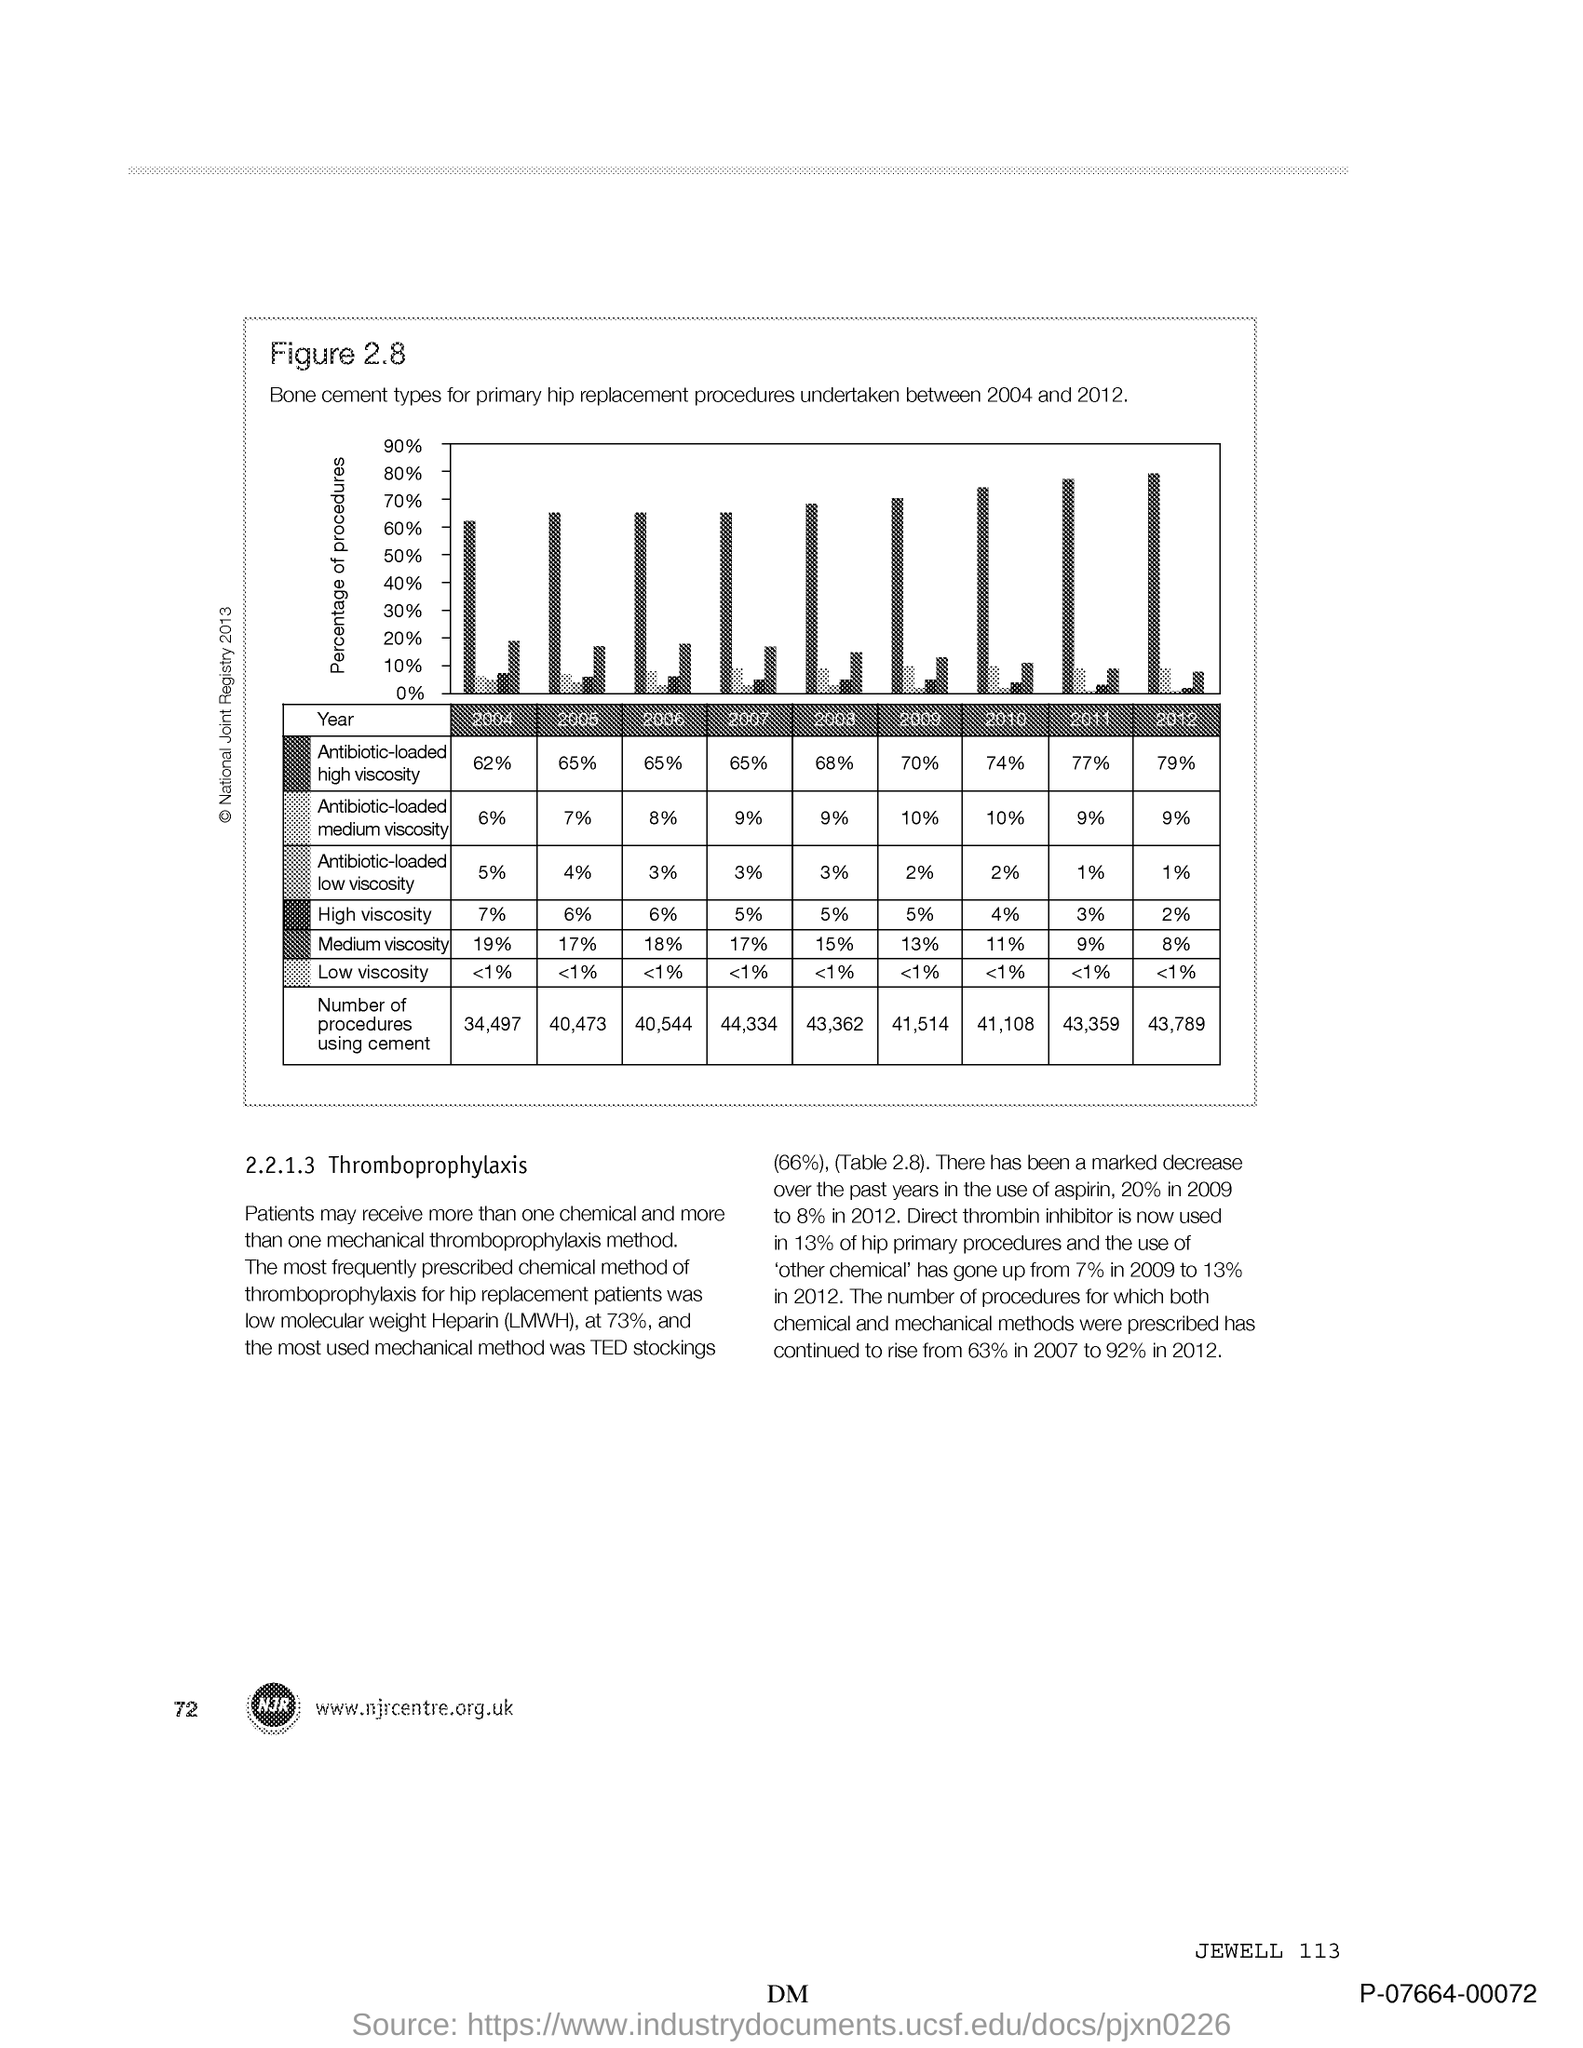What is plotted in the y-axis?
Make the answer very short. PERCENTAGE OF PROCEDURES. 